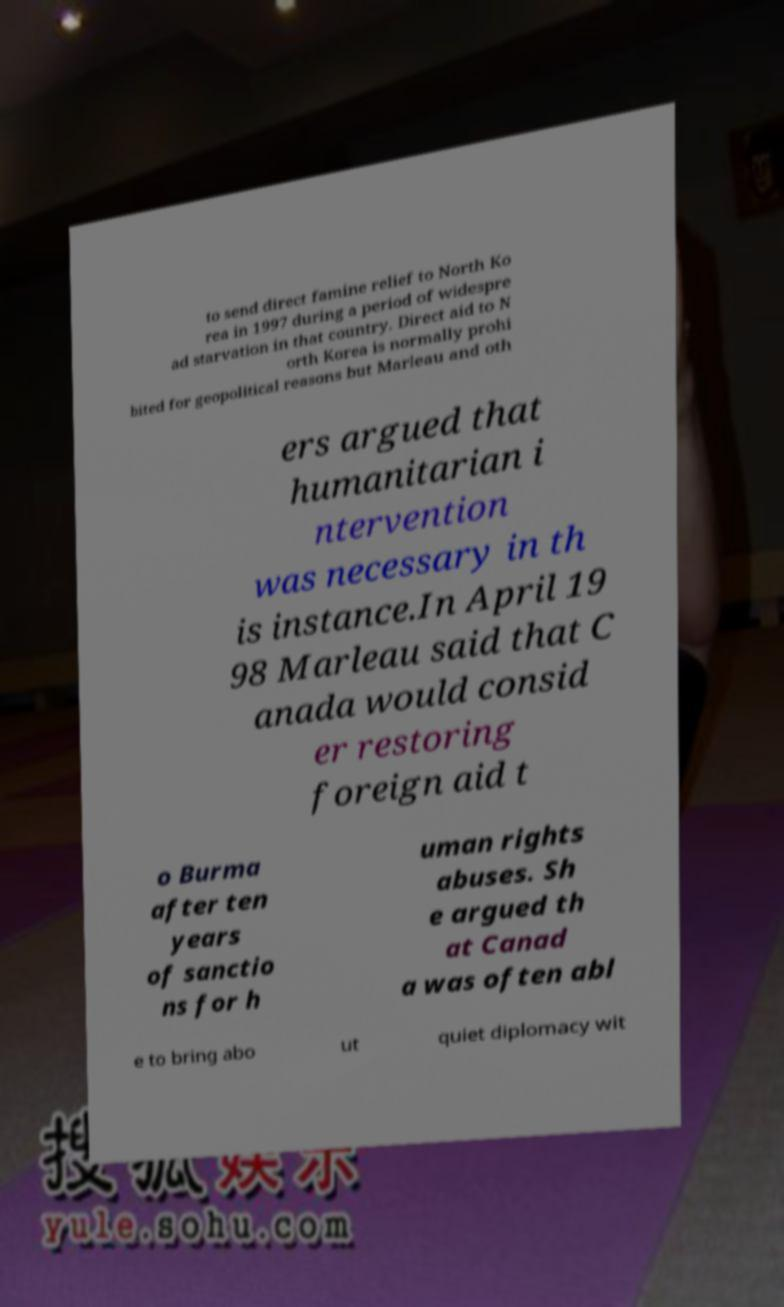What messages or text are displayed in this image? I need them in a readable, typed format. to send direct famine relief to North Ko rea in 1997 during a period of widespre ad starvation in that country. Direct aid to N orth Korea is normally prohi bited for geopolitical reasons but Marleau and oth ers argued that humanitarian i ntervention was necessary in th is instance.In April 19 98 Marleau said that C anada would consid er restoring foreign aid t o Burma after ten years of sanctio ns for h uman rights abuses. Sh e argued th at Canad a was often abl e to bring abo ut quiet diplomacy wit 